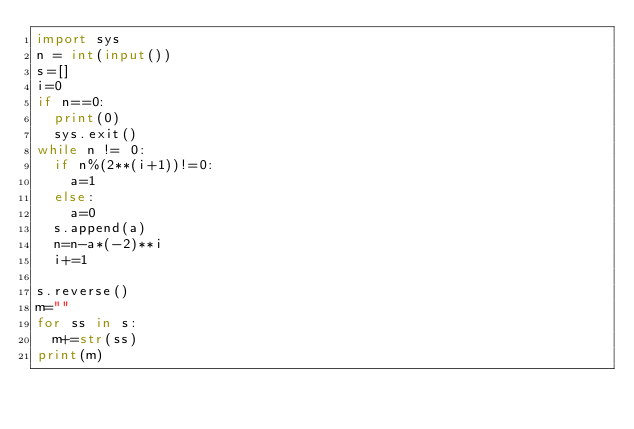<code> <loc_0><loc_0><loc_500><loc_500><_Python_>import sys
n = int(input())
s=[]
i=0
if n==0:
  print(0)
  sys.exit()
while n != 0:
  if n%(2**(i+1))!=0:
    a=1
  else:
    a=0
  s.append(a)
  n=n-a*(-2)**i
  i+=1

s.reverse()
m=""
for ss in s:
  m+=str(ss)
print(m)</code> 